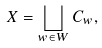Convert formula to latex. <formula><loc_0><loc_0><loc_500><loc_500>X = \bigsqcup _ { w \in W } C _ { w } ,</formula> 